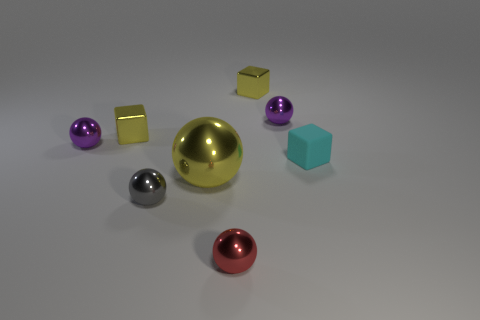Subtract all gray spheres. How many spheres are left? 4 Subtract 1 balls. How many balls are left? 4 Subtract all yellow spheres. How many spheres are left? 4 Subtract all green balls. Subtract all red cylinders. How many balls are left? 5 Add 1 gray objects. How many objects exist? 9 Subtract all spheres. How many objects are left? 3 Subtract 0 blue balls. How many objects are left? 8 Subtract all cyan rubber cubes. Subtract all gray balls. How many objects are left? 6 Add 1 blocks. How many blocks are left? 4 Add 1 large purple metal spheres. How many large purple metal spheres exist? 1 